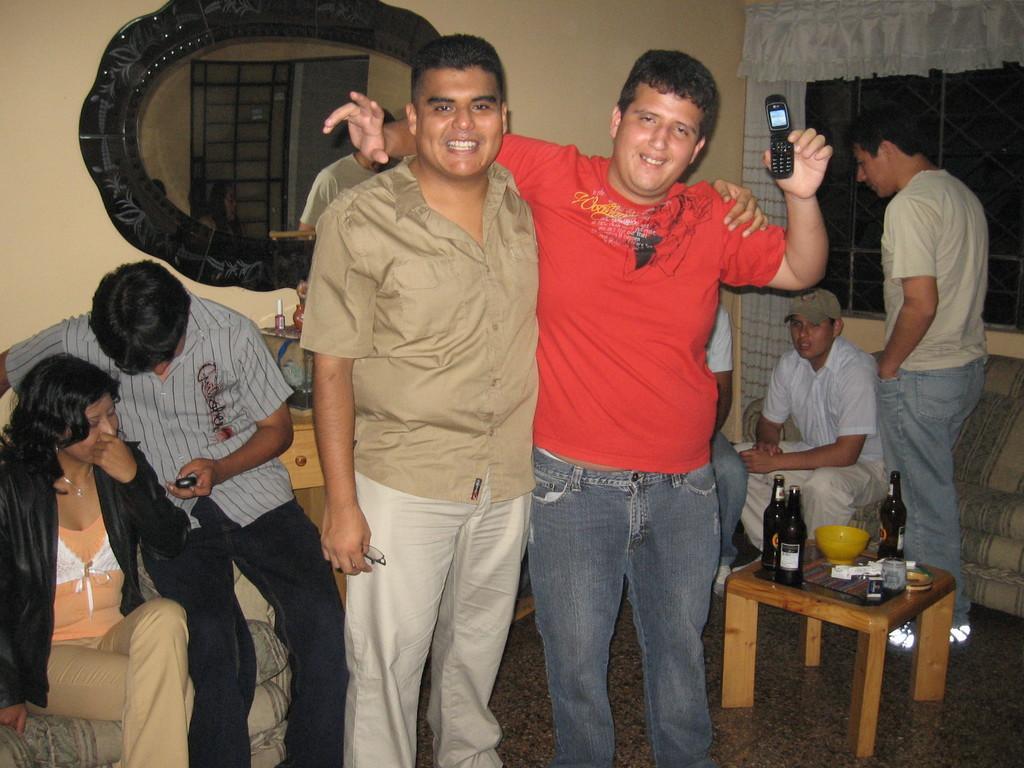Describe this image in one or two sentences. This picture is from a house. In the center of the picture there are two men standing and smiling, one is holding the mobile. On the left there are couple sitting in couch. On the right a man is standing and another man is sitting, on the right there is a couch. In the foreground there is a table, on the table there are bottles and bowl. On the right top there is curtain and window. On the top left there is a mirror. 